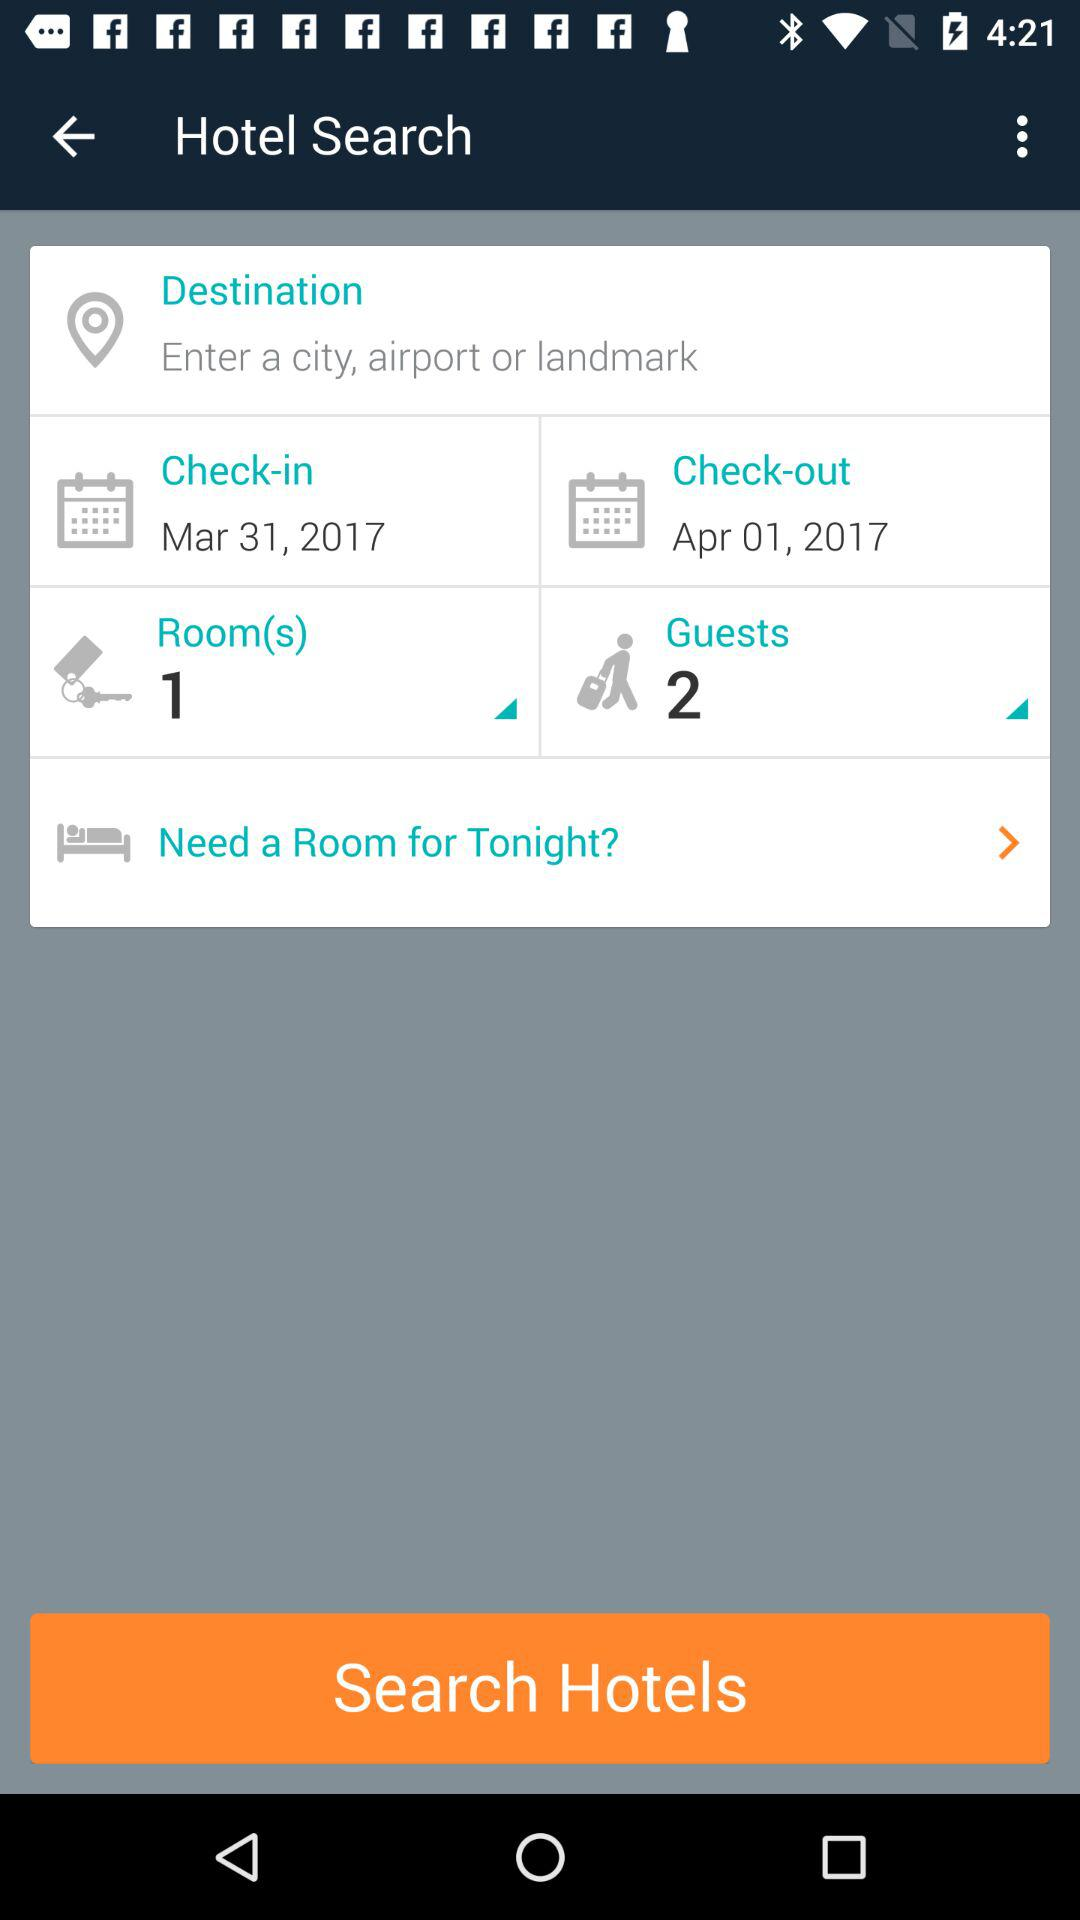What is the number of rooms? The number of rooms is 1. 